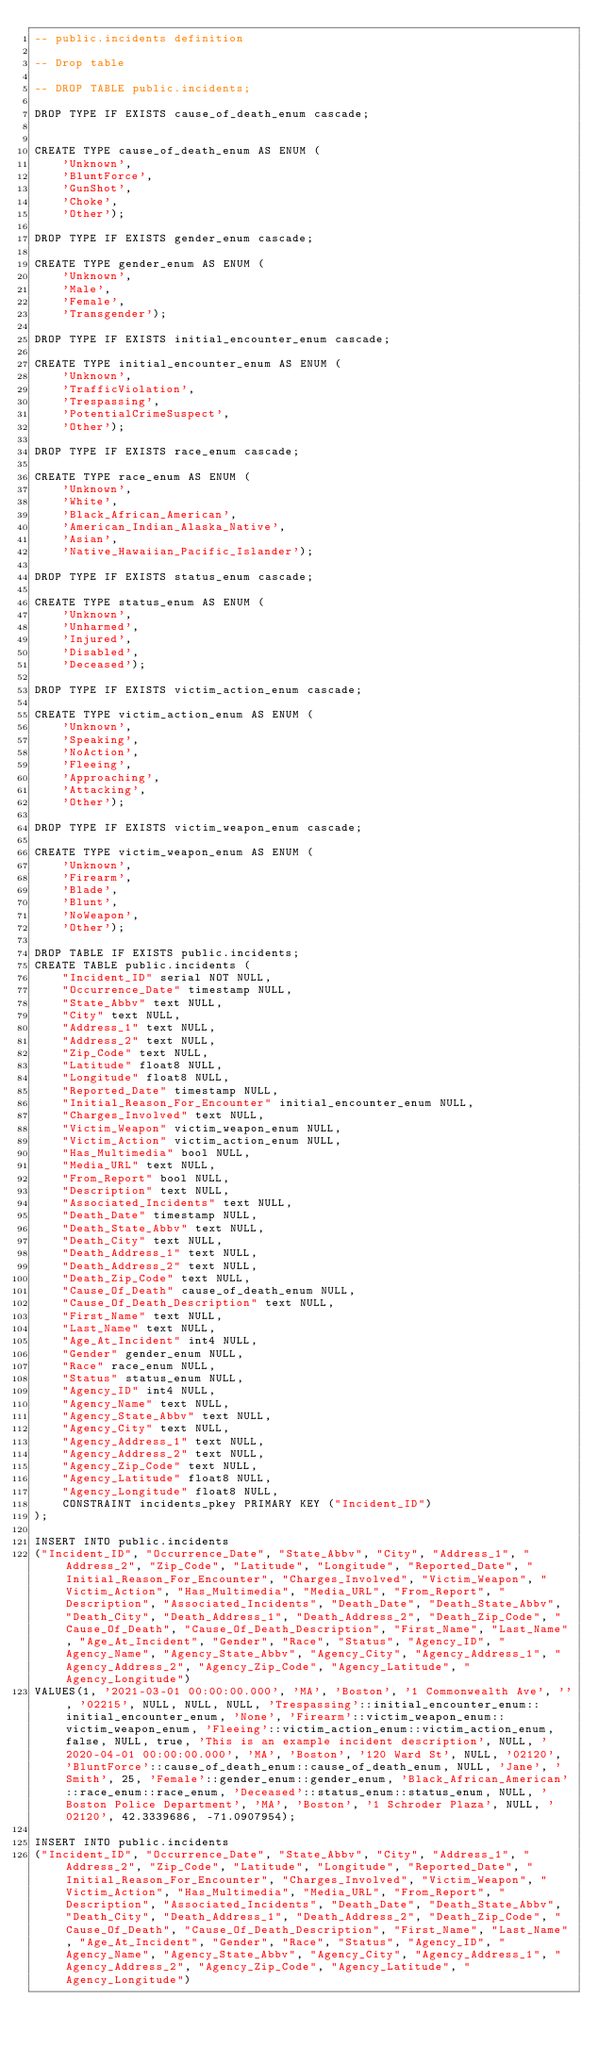<code> <loc_0><loc_0><loc_500><loc_500><_SQL_>-- public.incidents definition

-- Drop table

-- DROP TABLE public.incidents;

DROP TYPE IF EXISTS cause_of_death_enum cascade;


CREATE TYPE cause_of_death_enum AS ENUM (
	'Unknown',
	'BluntForce',
	'GunShot',
	'Choke',
	'Other');

DROP TYPE IF EXISTS gender_enum cascade;

CREATE TYPE gender_enum AS ENUM (
	'Unknown',
	'Male',
	'Female',
	'Transgender');

DROP TYPE IF EXISTS initial_encounter_enum cascade;

CREATE TYPE initial_encounter_enum AS ENUM (
	'Unknown',
	'TrafficViolation',
	'Trespassing',
	'PotentialCrimeSuspect',
	'Other');

DROP TYPE IF EXISTS race_enum cascade;

CREATE TYPE race_enum AS ENUM (
	'Unknown',
	'White',
	'Black_African_American',
	'American_Indian_Alaska_Native',
	'Asian',
	'Native_Hawaiian_Pacific_Islander');

DROP TYPE IF EXISTS status_enum cascade;

CREATE TYPE status_enum AS ENUM (
	'Unknown',
	'Unharmed',
	'Injured',
	'Disabled',
	'Deceased');

DROP TYPE IF EXISTS victim_action_enum cascade;

CREATE TYPE victim_action_enum AS ENUM (
	'Unknown',
	'Speaking',
	'NoAction',
	'Fleeing',
	'Approaching',
	'Attacking',
	'Other');

DROP TYPE IF EXISTS victim_weapon_enum cascade;

CREATE TYPE victim_weapon_enum AS ENUM (
	'Unknown',
	'Firearm',
	'Blade',
	'Blunt',
	'NoWeapon',
	'Other');

DROP TABLE IF EXISTS public.incidents;
CREATE TABLE public.incidents (
	"Incident_ID" serial NOT NULL,
	"Occurrence_Date" timestamp NULL,
	"State_Abbv" text NULL,
	"City" text NULL,
	"Address_1" text NULL,
	"Address_2" text NULL,
	"Zip_Code" text NULL,
	"Latitude" float8 NULL,
	"Longitude" float8 NULL,
	"Reported_Date" timestamp NULL,
	"Initial_Reason_For_Encounter" initial_encounter_enum NULL,
	"Charges_Involved" text NULL,
	"Victim_Weapon" victim_weapon_enum NULL,
	"Victim_Action" victim_action_enum NULL,
	"Has_Multimedia" bool NULL,
	"Media_URL" text NULL,
	"From_Report" bool NULL,
	"Description" text NULL,
	"Associated_Incidents" text NULL,
	"Death_Date" timestamp NULL,
	"Death_State_Abbv" text NULL,
	"Death_City" text NULL,
	"Death_Address_1" text NULL,
	"Death_Address_2" text NULL,
	"Death_Zip_Code" text NULL,
	"Cause_Of_Death" cause_of_death_enum NULL,
	"Cause_Of_Death_Description" text NULL,
	"First_Name" text NULL,
	"Last_Name" text NULL,
	"Age_At_Incident" int4 NULL,
	"Gender" gender_enum NULL,
	"Race" race_enum NULL,
	"Status" status_enum NULL,
	"Agency_ID" int4 NULL,
	"Agency_Name" text NULL,
	"Agency_State_Abbv" text NULL,
	"Agency_City" text NULL,
	"Agency_Address_1" text NULL,
	"Agency_Address_2" text NULL,
	"Agency_Zip_Code" text NULL,
	"Agency_Latitude" float8 NULL,
	"Agency_Longitude" float8 NULL,
	CONSTRAINT incidents_pkey PRIMARY KEY ("Incident_ID")
);

INSERT INTO public.incidents
("Incident_ID", "Occurrence_Date", "State_Abbv", "City", "Address_1", "Address_2", "Zip_Code", "Latitude", "Longitude", "Reported_Date", "Initial_Reason_For_Encounter", "Charges_Involved", "Victim_Weapon", "Victim_Action", "Has_Multimedia", "Media_URL", "From_Report", "Description", "Associated_Incidents", "Death_Date", "Death_State_Abbv", "Death_City", "Death_Address_1", "Death_Address_2", "Death_Zip_Code", "Cause_Of_Death", "Cause_Of_Death_Description", "First_Name", "Last_Name", "Age_At_Incident", "Gender", "Race", "Status", "Agency_ID", "Agency_Name", "Agency_State_Abbv", "Agency_City", "Agency_Address_1", "Agency_Address_2", "Agency_Zip_Code", "Agency_Latitude", "Agency_Longitude")
VALUES(1, '2021-03-01 00:00:00.000', 'MA', 'Boston', '1 Commonwealth Ave', '', '02215', NULL, NULL, NULL, 'Trespassing'::initial_encounter_enum::initial_encounter_enum, 'None', 'Firearm'::victim_weapon_enum::victim_weapon_enum, 'Fleeing'::victim_action_enum::victim_action_enum, false, NULL, true, 'This is an example incident description', NULL, '2020-04-01 00:00:00.000', 'MA', 'Boston', '120 Ward St', NULL, '02120', 'BluntForce'::cause_of_death_enum::cause_of_death_enum, NULL, 'Jane', 'Smith', 25, 'Female'::gender_enum::gender_enum, 'Black_African_American'::race_enum::race_enum, 'Deceased'::status_enum::status_enum, NULL, 'Boston Police Department', 'MA', 'Boston', '1 Schroder Plaza', NULL, '02120', 42.3339686, -71.0907954);

INSERT INTO public.incidents
("Incident_ID", "Occurrence_Date", "State_Abbv", "City", "Address_1", "Address_2", "Zip_Code", "Latitude", "Longitude", "Reported_Date", "Initial_Reason_For_Encounter", "Charges_Involved", "Victim_Weapon", "Victim_Action", "Has_Multimedia", "Media_URL", "From_Report", "Description", "Associated_Incidents", "Death_Date", "Death_State_Abbv", "Death_City", "Death_Address_1", "Death_Address_2", "Death_Zip_Code", "Cause_Of_Death", "Cause_Of_Death_Description", "First_Name", "Last_Name", "Age_At_Incident", "Gender", "Race", "Status", "Agency_ID", "Agency_Name", "Agency_State_Abbv", "Agency_City", "Agency_Address_1", "Agency_Address_2", "Agency_Zip_Code", "Agency_Latitude", "Agency_Longitude")</code> 